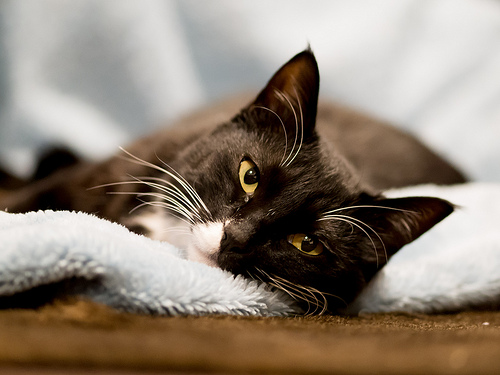<image>
Is there a cat in the carpet? No. The cat is not contained within the carpet. These objects have a different spatial relationship. 